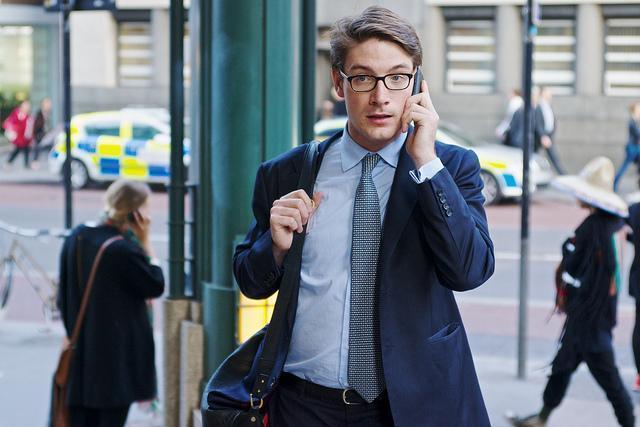How many are smoking?
Give a very brief answer. 0. How many cars are visible?
Give a very brief answer. 2. How many people can you see?
Give a very brief answer. 3. How many handbags can be seen?
Give a very brief answer. 1. How many brown horses are there?
Give a very brief answer. 0. 